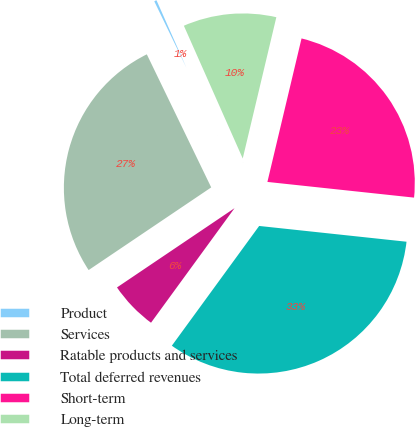Convert chart. <chart><loc_0><loc_0><loc_500><loc_500><pie_chart><fcel>Product<fcel>Services<fcel>Ratable products and services<fcel>Total deferred revenues<fcel>Short-term<fcel>Long-term<nl><fcel>0.53%<fcel>27.27%<fcel>5.53%<fcel>33.33%<fcel>22.98%<fcel>10.36%<nl></chart> 